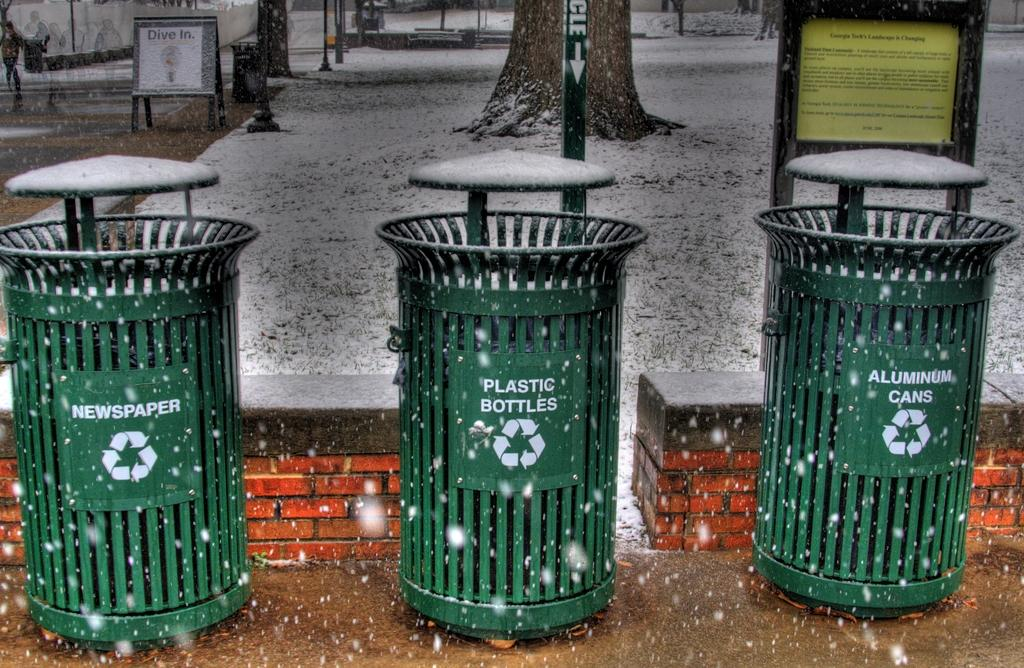<image>
Give a short and clear explanation of the subsequent image. Three green garbage cans which says "Aluminum Cans" on it. 